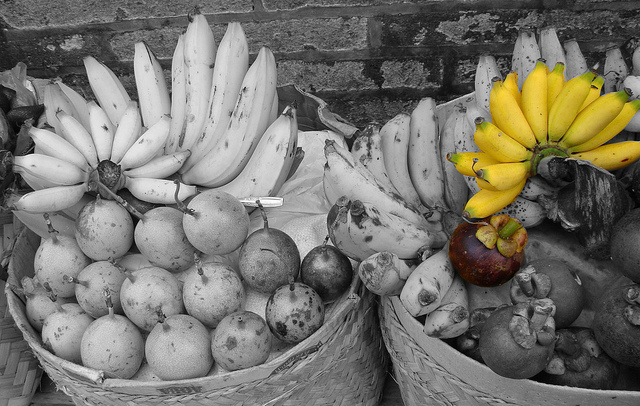Please provide a short description for this region: [0.26, 0.19, 0.47, 0.52]. The highest three bananas sticking up in the left basket. 